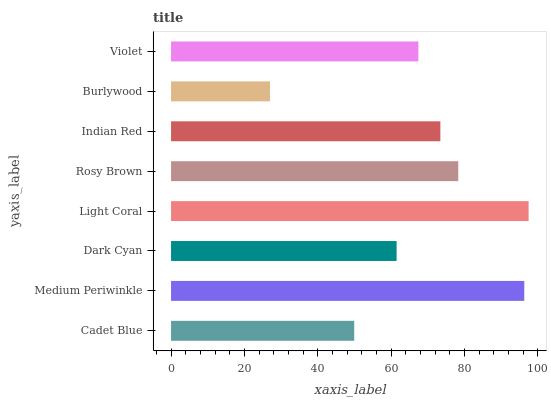Is Burlywood the minimum?
Answer yes or no. Yes. Is Light Coral the maximum?
Answer yes or no. Yes. Is Medium Periwinkle the minimum?
Answer yes or no. No. Is Medium Periwinkle the maximum?
Answer yes or no. No. Is Medium Periwinkle greater than Cadet Blue?
Answer yes or no. Yes. Is Cadet Blue less than Medium Periwinkle?
Answer yes or no. Yes. Is Cadet Blue greater than Medium Periwinkle?
Answer yes or no. No. Is Medium Periwinkle less than Cadet Blue?
Answer yes or no. No. Is Indian Red the high median?
Answer yes or no. Yes. Is Violet the low median?
Answer yes or no. Yes. Is Violet the high median?
Answer yes or no. No. Is Dark Cyan the low median?
Answer yes or no. No. 